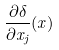<formula> <loc_0><loc_0><loc_500><loc_500>\frac { \partial \delta } { \partial x _ { j } } ( x )</formula> 